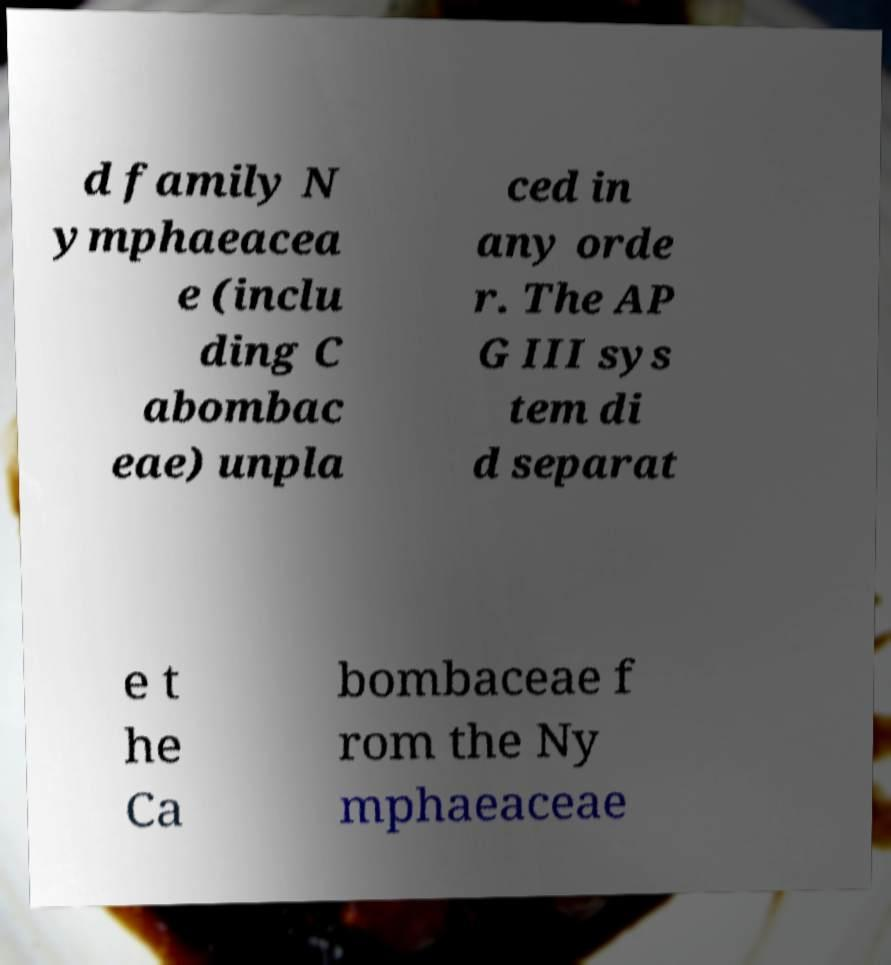Please identify and transcribe the text found in this image. d family N ymphaeacea e (inclu ding C abombac eae) unpla ced in any orde r. The AP G III sys tem di d separat e t he Ca bombaceae f rom the Ny mphaeaceae 